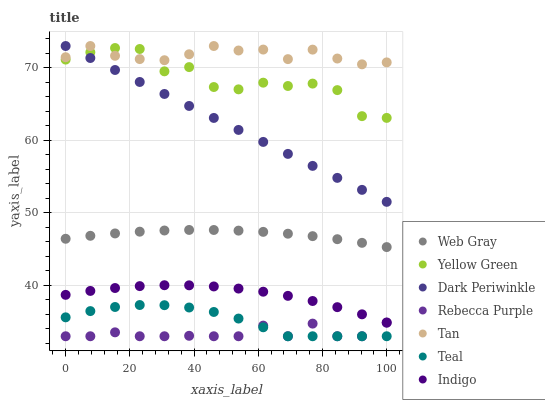Does Rebecca Purple have the minimum area under the curve?
Answer yes or no. Yes. Does Tan have the maximum area under the curve?
Answer yes or no. Yes. Does Indigo have the minimum area under the curve?
Answer yes or no. No. Does Indigo have the maximum area under the curve?
Answer yes or no. No. Is Dark Periwinkle the smoothest?
Answer yes or no. Yes. Is Yellow Green the roughest?
Answer yes or no. Yes. Is Indigo the smoothest?
Answer yes or no. No. Is Indigo the roughest?
Answer yes or no. No. Does Rebecca Purple have the lowest value?
Answer yes or no. Yes. Does Indigo have the lowest value?
Answer yes or no. No. Does Dark Periwinkle have the highest value?
Answer yes or no. Yes. Does Indigo have the highest value?
Answer yes or no. No. Is Teal less than Indigo?
Answer yes or no. Yes. Is Indigo greater than Teal?
Answer yes or no. Yes. Does Yellow Green intersect Dark Periwinkle?
Answer yes or no. Yes. Is Yellow Green less than Dark Periwinkle?
Answer yes or no. No. Is Yellow Green greater than Dark Periwinkle?
Answer yes or no. No. Does Teal intersect Indigo?
Answer yes or no. No. 